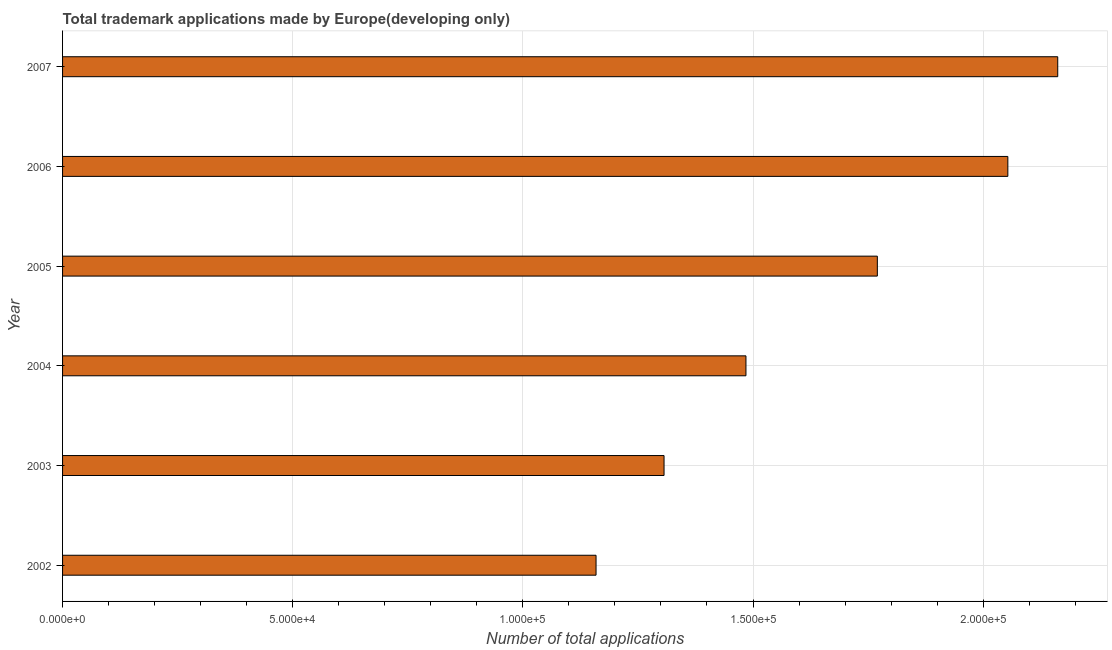Does the graph contain grids?
Your answer should be compact. Yes. What is the title of the graph?
Make the answer very short. Total trademark applications made by Europe(developing only). What is the label or title of the X-axis?
Ensure brevity in your answer.  Number of total applications. What is the number of trademark applications in 2007?
Give a very brief answer. 2.16e+05. Across all years, what is the maximum number of trademark applications?
Provide a short and direct response. 2.16e+05. Across all years, what is the minimum number of trademark applications?
Provide a short and direct response. 1.16e+05. In which year was the number of trademark applications maximum?
Give a very brief answer. 2007. In which year was the number of trademark applications minimum?
Your answer should be very brief. 2002. What is the sum of the number of trademark applications?
Your answer should be very brief. 9.94e+05. What is the difference between the number of trademark applications in 2002 and 2007?
Provide a short and direct response. -1.00e+05. What is the average number of trademark applications per year?
Provide a succinct answer. 1.66e+05. What is the median number of trademark applications?
Provide a succinct answer. 1.63e+05. What is the ratio of the number of trademark applications in 2005 to that in 2006?
Ensure brevity in your answer.  0.86. What is the difference between the highest and the second highest number of trademark applications?
Give a very brief answer. 1.08e+04. What is the difference between the highest and the lowest number of trademark applications?
Keep it short and to the point. 1.00e+05. In how many years, is the number of trademark applications greater than the average number of trademark applications taken over all years?
Your answer should be very brief. 3. How many bars are there?
Your answer should be compact. 6. How many years are there in the graph?
Your response must be concise. 6. What is the difference between two consecutive major ticks on the X-axis?
Your answer should be compact. 5.00e+04. Are the values on the major ticks of X-axis written in scientific E-notation?
Provide a succinct answer. Yes. What is the Number of total applications in 2002?
Your answer should be very brief. 1.16e+05. What is the Number of total applications of 2003?
Provide a short and direct response. 1.31e+05. What is the Number of total applications in 2004?
Give a very brief answer. 1.48e+05. What is the Number of total applications in 2005?
Provide a succinct answer. 1.77e+05. What is the Number of total applications of 2006?
Ensure brevity in your answer.  2.05e+05. What is the Number of total applications of 2007?
Your answer should be compact. 2.16e+05. What is the difference between the Number of total applications in 2002 and 2003?
Provide a succinct answer. -1.48e+04. What is the difference between the Number of total applications in 2002 and 2004?
Ensure brevity in your answer.  -3.26e+04. What is the difference between the Number of total applications in 2002 and 2005?
Your response must be concise. -6.11e+04. What is the difference between the Number of total applications in 2002 and 2006?
Provide a succinct answer. -8.95e+04. What is the difference between the Number of total applications in 2002 and 2007?
Your answer should be very brief. -1.00e+05. What is the difference between the Number of total applications in 2003 and 2004?
Your response must be concise. -1.78e+04. What is the difference between the Number of total applications in 2003 and 2005?
Your response must be concise. -4.63e+04. What is the difference between the Number of total applications in 2003 and 2006?
Provide a succinct answer. -7.47e+04. What is the difference between the Number of total applications in 2003 and 2007?
Provide a succinct answer. -8.55e+04. What is the difference between the Number of total applications in 2004 and 2005?
Offer a terse response. -2.85e+04. What is the difference between the Number of total applications in 2004 and 2006?
Provide a succinct answer. -5.69e+04. What is the difference between the Number of total applications in 2004 and 2007?
Offer a terse response. -6.77e+04. What is the difference between the Number of total applications in 2005 and 2006?
Your answer should be compact. -2.84e+04. What is the difference between the Number of total applications in 2005 and 2007?
Your answer should be compact. -3.92e+04. What is the difference between the Number of total applications in 2006 and 2007?
Give a very brief answer. -1.08e+04. What is the ratio of the Number of total applications in 2002 to that in 2003?
Your answer should be very brief. 0.89. What is the ratio of the Number of total applications in 2002 to that in 2004?
Provide a short and direct response. 0.78. What is the ratio of the Number of total applications in 2002 to that in 2005?
Offer a very short reply. 0.66. What is the ratio of the Number of total applications in 2002 to that in 2006?
Offer a very short reply. 0.56. What is the ratio of the Number of total applications in 2002 to that in 2007?
Make the answer very short. 0.54. What is the ratio of the Number of total applications in 2003 to that in 2004?
Ensure brevity in your answer.  0.88. What is the ratio of the Number of total applications in 2003 to that in 2005?
Make the answer very short. 0.74. What is the ratio of the Number of total applications in 2003 to that in 2006?
Offer a terse response. 0.64. What is the ratio of the Number of total applications in 2003 to that in 2007?
Your answer should be very brief. 0.6. What is the ratio of the Number of total applications in 2004 to that in 2005?
Offer a terse response. 0.84. What is the ratio of the Number of total applications in 2004 to that in 2006?
Give a very brief answer. 0.72. What is the ratio of the Number of total applications in 2004 to that in 2007?
Your response must be concise. 0.69. What is the ratio of the Number of total applications in 2005 to that in 2006?
Offer a terse response. 0.86. What is the ratio of the Number of total applications in 2005 to that in 2007?
Provide a short and direct response. 0.82. 